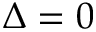Convert formula to latex. <formula><loc_0><loc_0><loc_500><loc_500>\Delta = 0</formula> 